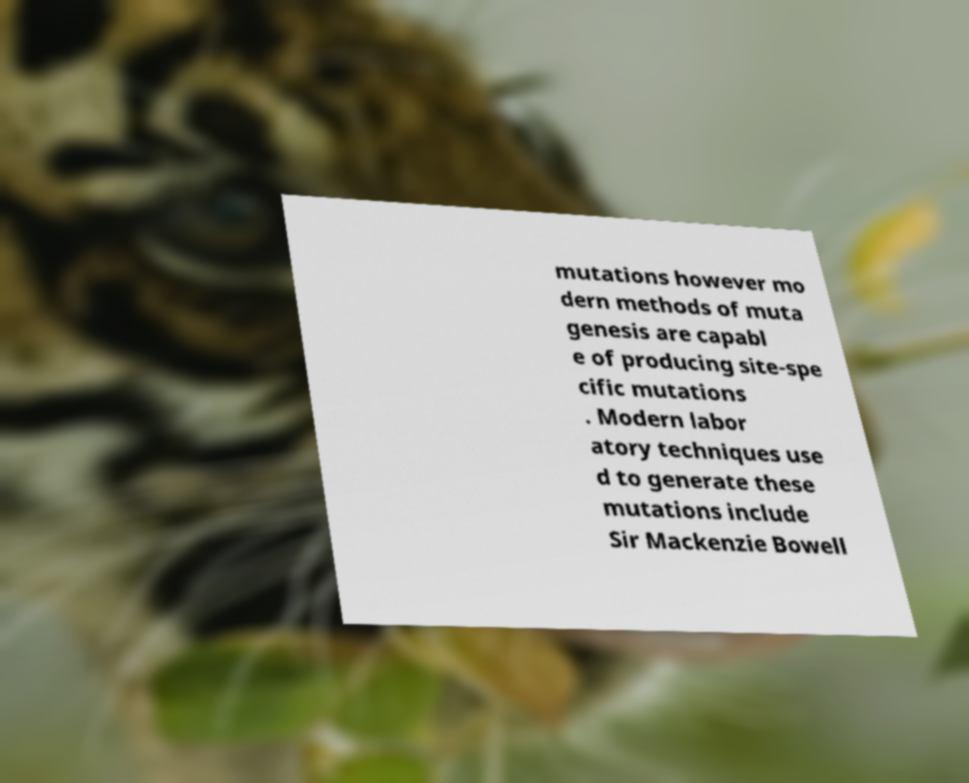Could you extract and type out the text from this image? mutations however mo dern methods of muta genesis are capabl e of producing site-spe cific mutations . Modern labor atory techniques use d to generate these mutations include Sir Mackenzie Bowell 